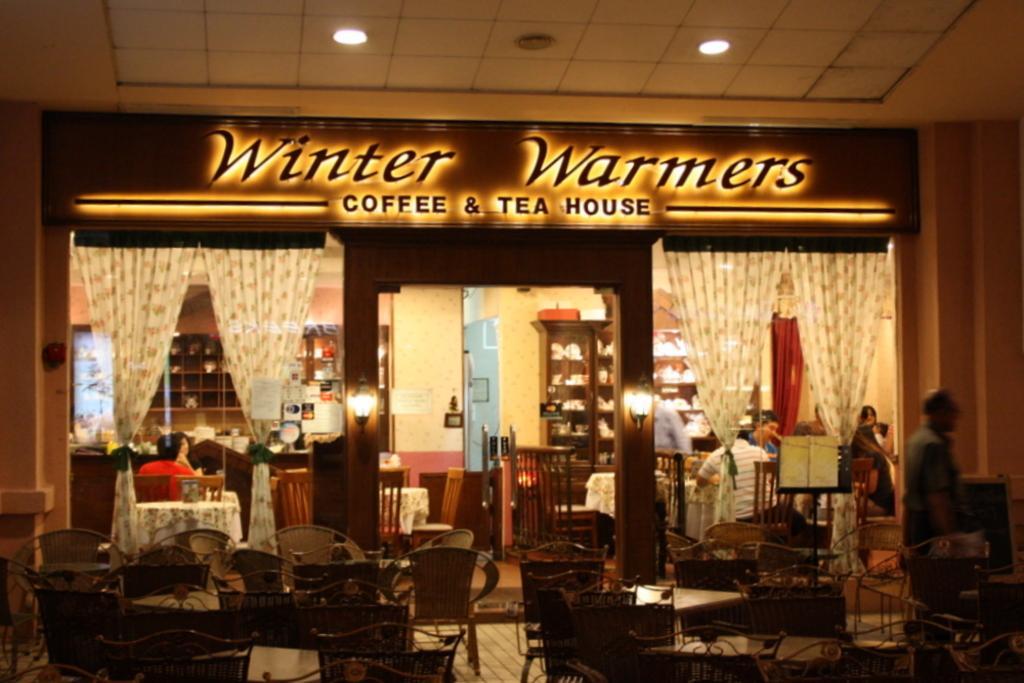Describe this image in one or two sentences. At the top we can see ceiling and lights. This is a store. Here we can see cupboards, tables and chairs and few people are sitting on the chairs. These are curtains. Near to the store we can see empty chairs and tables. 